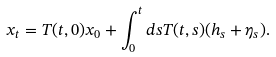Convert formula to latex. <formula><loc_0><loc_0><loc_500><loc_500>x _ { t } = T ( t , 0 ) x _ { 0 } + \int _ { 0 } ^ { t } d s T ( t , s ) ( h _ { s } + \eta _ { s } ) .</formula> 